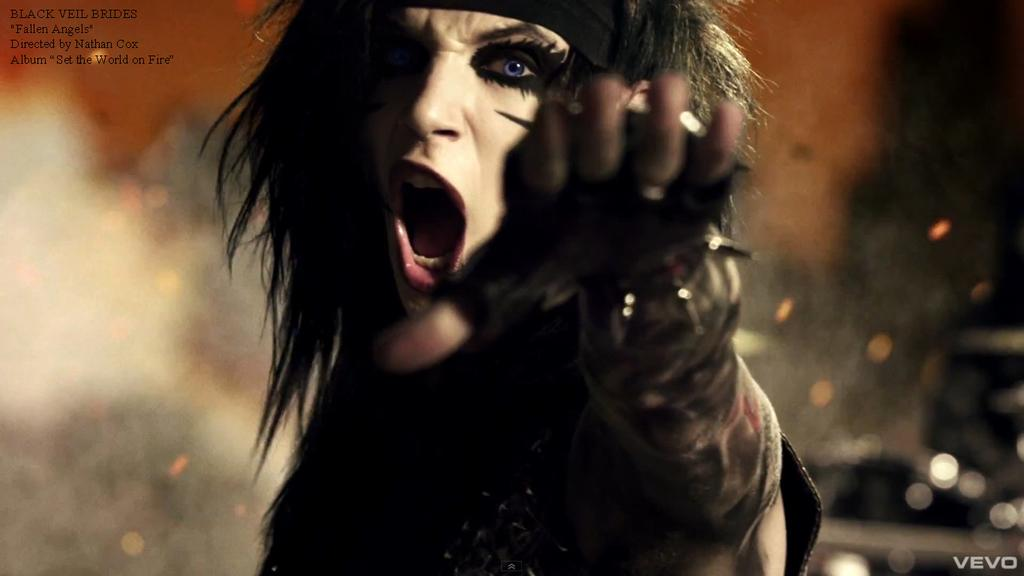What is the main subject of the image? There is a person in the image. Can you describe the background of the image? The background of the image is blurred. Are there any additional features on the image itself? Yes, there are watermarks on the image. What type of birthday celebration is taking place in the image? There is no indication of a birthday celebration in the image; it only features a person with a blurred background and watermarks. Can you see any waves in the image? There are no waves visible in the image; it does not depict a water-related scene. 